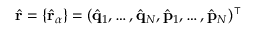<formula> <loc_0><loc_0><loc_500><loc_500>\hat { r } = \{ \hat { r } _ { \alpha } \} = ( \hat { q } _ { 1 } , \dots , \hat { q } _ { N } , \hat { p } _ { 1 } , \dots , \hat { p } _ { N } ) ^ { \intercal }</formula> 